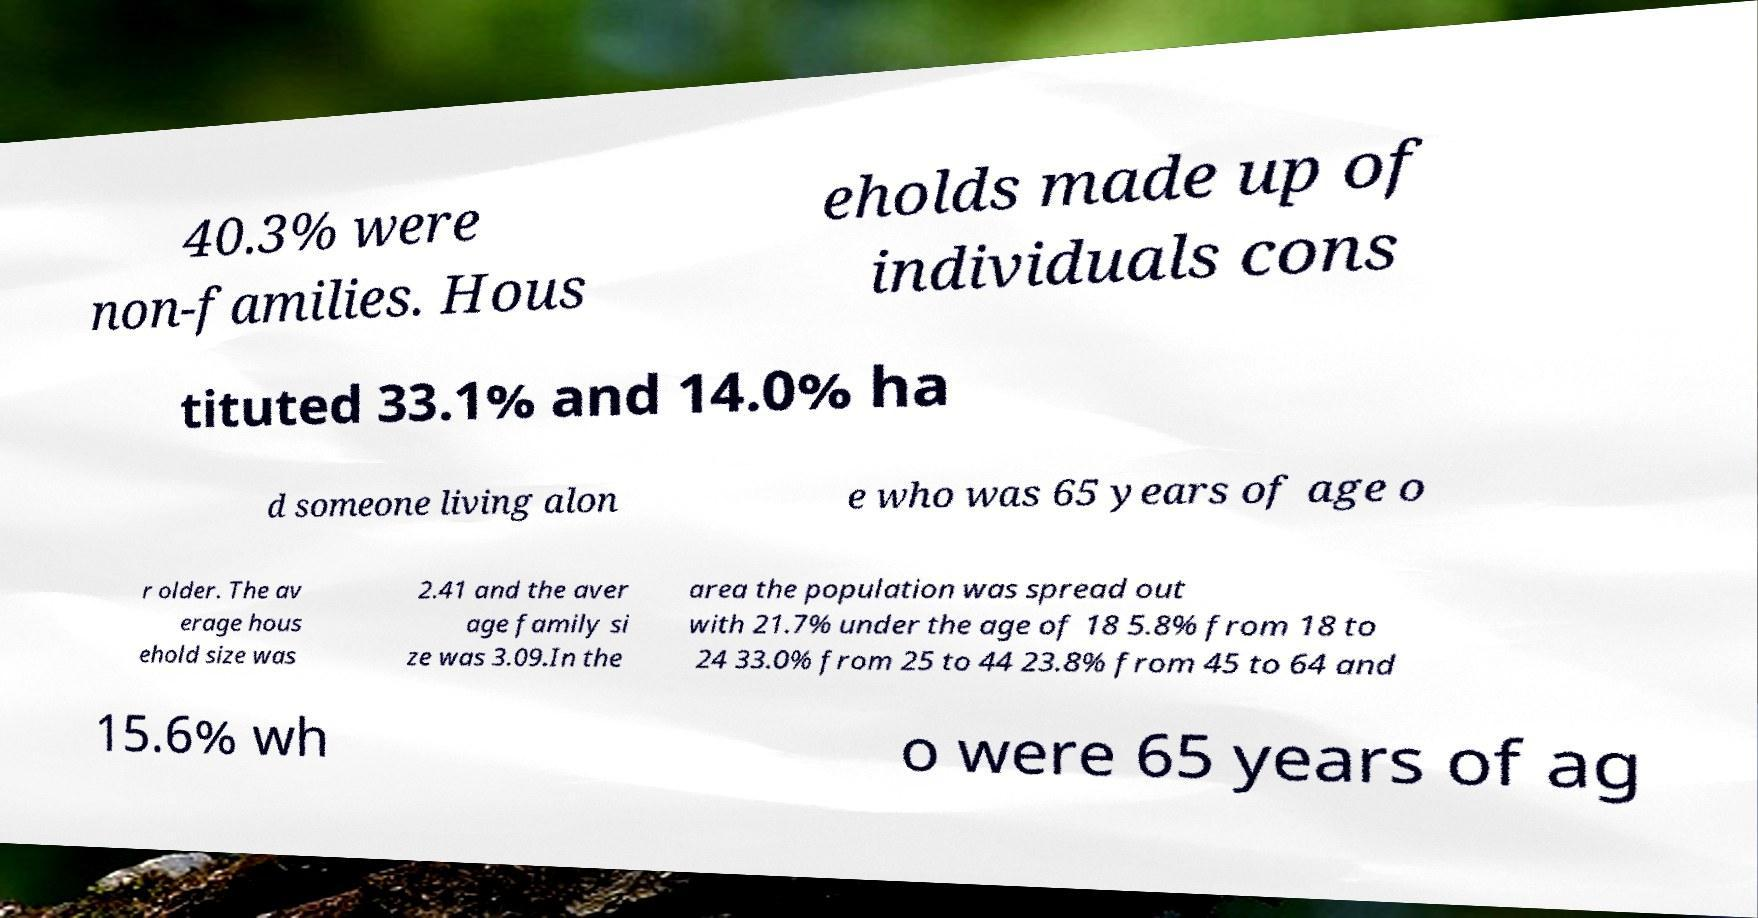There's text embedded in this image that I need extracted. Can you transcribe it verbatim? 40.3% were non-families. Hous eholds made up of individuals cons tituted 33.1% and 14.0% ha d someone living alon e who was 65 years of age o r older. The av erage hous ehold size was 2.41 and the aver age family si ze was 3.09.In the area the population was spread out with 21.7% under the age of 18 5.8% from 18 to 24 33.0% from 25 to 44 23.8% from 45 to 64 and 15.6% wh o were 65 years of ag 